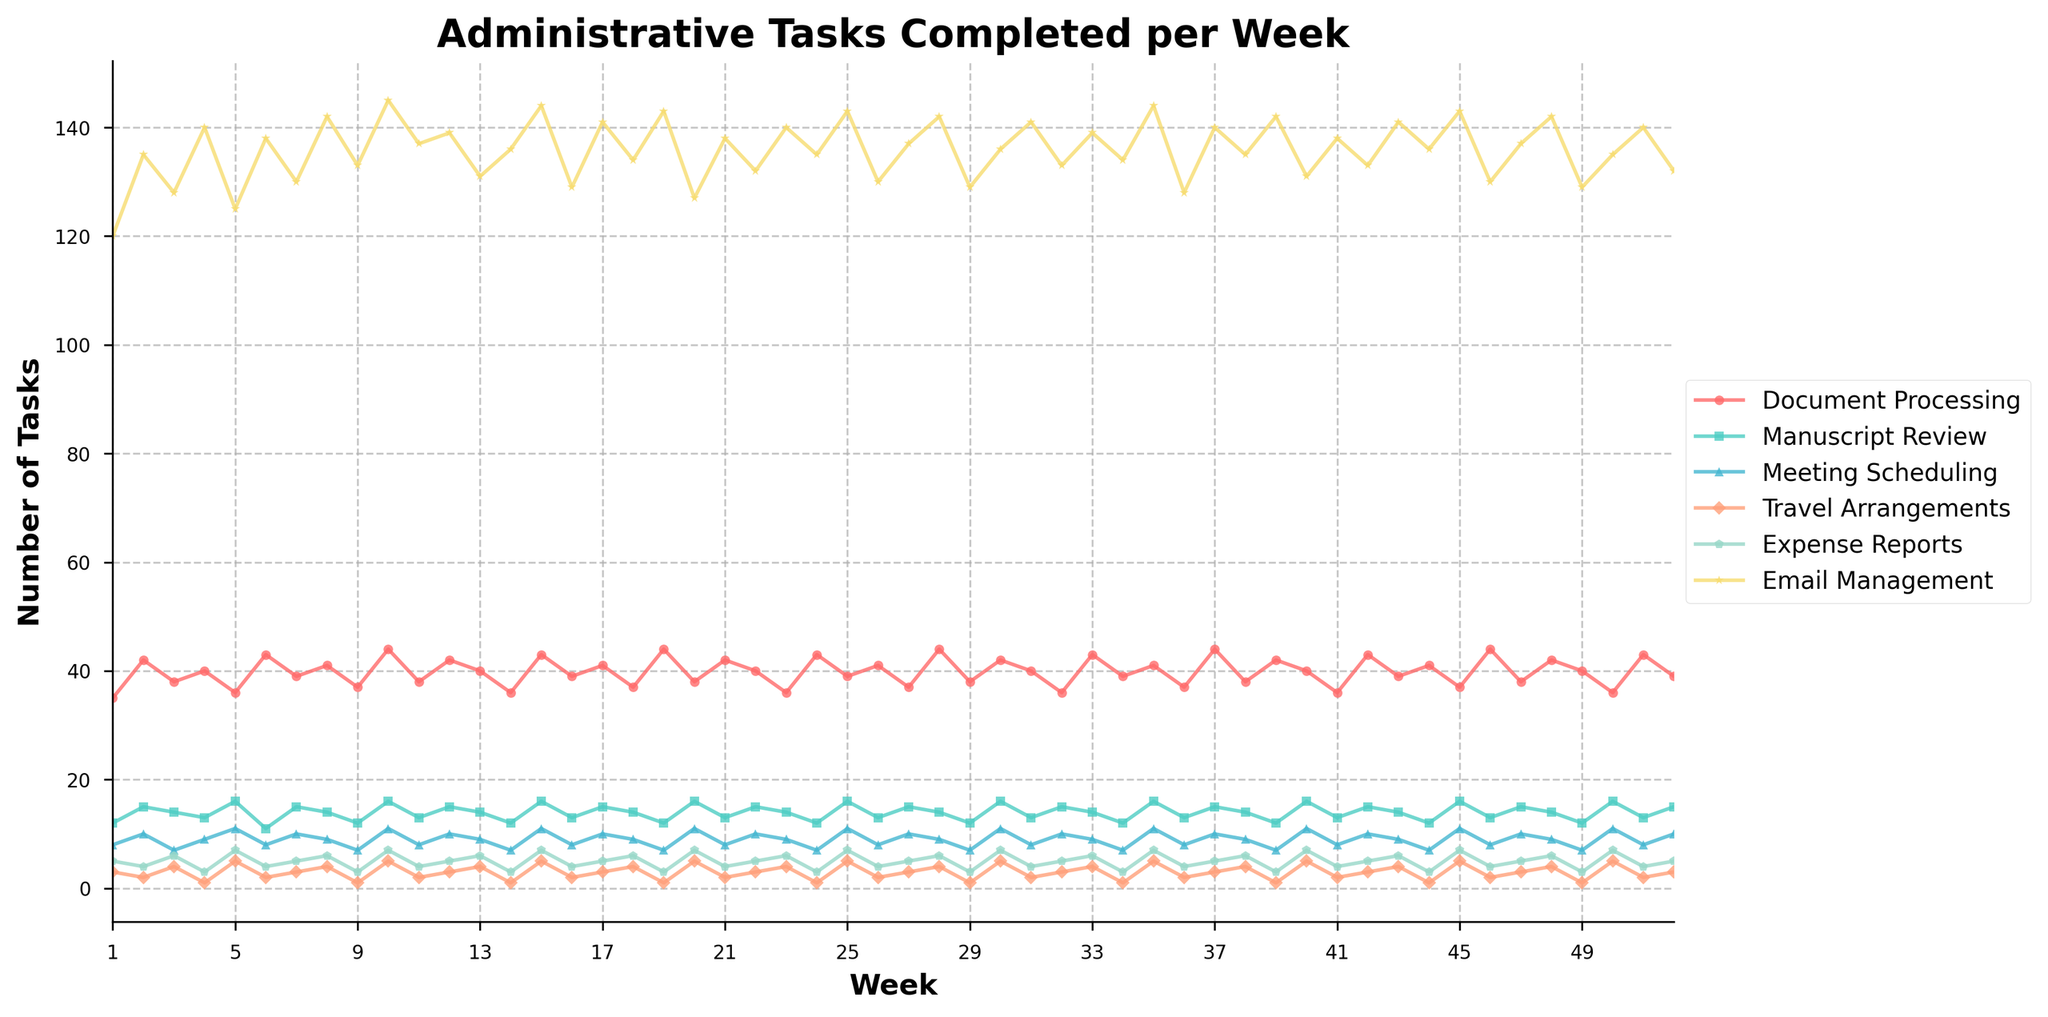How many more Email Management tasks were completed in Week 10 compared to Week 1? To determine the difference, find the number of Email Management tasks for Week 10 (145) and Week 1 (120), then subtract the two: 145 - 120 = 25
Answer: 25 Which task type had the most variation in the number of tasks completed over the 52 weeks? To find the task type with the most variation, examine the range of values (max - min) for each task. Document Processing ranges from 36 to 44, Manuscript Review from 11 to 16, Meeting Scheduling from 7 to 11, Travel Arrangements from 1 to 5, Expense Reports from 3 to 7, Email Management from 120 to 145. Email Management has the largest range: 145 - 120 = 25
Answer: Email Management During which week was the peak number of Meeting Scheduling tasks completed? Locate the highest peak in the plot for Meeting Scheduling (shown with a specific marker and color). The peak for Meeting Scheduling is Week 10 with 11 tasks.
Answer: Week 10 On average, how many Manuscript Review tasks were completed each week? Sum the numbers for Manuscript Review for all weeks and divide by 52. The sum is \(12 + 15 + 14 + 13 + 16 + 11 + 15 + 14 + 12 + 16 + 13 + 15 + 14 + 12 + 16 + 13 + 15 + 14 + 12 + 16 + 13 + 15 + 14 + 12 + 16 + 13 + 15 + 14 + 12 + 16 + 13 + 15 + 14 + 12 + 16 + 13 + 15 + 12 + 13 + 15 + 14 + 12 + 16 + 15 = 744\); 744 / 52 = 14.31
Answer: 14.31 What is the trend of Travel Arrangements tasks over the 52 weeks? Analyze the overall direction by looking at the plot for Travel Arrangements (color-coded). Although there are fluctuations, there does not appear to be a clear increasing or decreasing trend for Travel Arrangements tasks over the year.
Answer: No clear trend What was the total number of Document Processing tasks completed in the first 10 weeks? Add the numbers from the Document Processing column for Weeks 1 to 10: \(35 + 42 + 38 + 40 + 36 + 43 + 39 + 41 + 37 + 44 = 395\)
Answer: 395 In which week was the fewest number of Expense Reports tasks completed? Locate the lowest value in the Expense Reports plot. The minimum value is 1, which occurs in several weeks (Week 4, Week 9, Week 14, Week 19, Week 24, etc.).
Answer: Week 4 (and others) Compare the total number of tasks completed for Meeting Scheduling and Travel Arrangements over the fiscal year. Which one had more tasks completed? Sum the numbers for both categories over all 52 weeks and compare: Meeting Scheduling total = \(8 + 10 + 7 + 9 + 11 + 8 + 10 + 9 + 7 + 11 + 8 + 10 + 9 + 7 + 11 + 8 + 10 + 9 + 7 + 11 + 8 + 10 + 9 + 7 + 11 + 8 + 10 + 9 + 7 + 11 + 8 + 10 + 9 + 7 + 11 + 8 + 10 + 9 + 7 + 11 + 8 + 10 + 9 + 7 + 11 + 8 + 10 = 394\); Travel Arrangements total = \(3 + 2 + 4 + 1 + 5 + 2 + 3 + 4 + 1 + 5 + 2 + 3 + 4 + 1 + 5 + 2 + 3 + 4 + 1 + 5 + 2 + 3 + 4 + 1 + 5 + 2 + 3 + 4 + 1 + 5 + 2 + 3 + 4 + 1 + 5 + 2 + 3 + 4 + 1 + 5 + 2 + 3 + 4 + 1 + 5 + 2 + 3 = 156\); 394 > 156 so Meeting Scheduling had more
Answer: Meeting Scheduling 